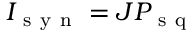<formula> <loc_0><loc_0><loc_500><loc_500>I _ { s y n } = J P _ { s q }</formula> 